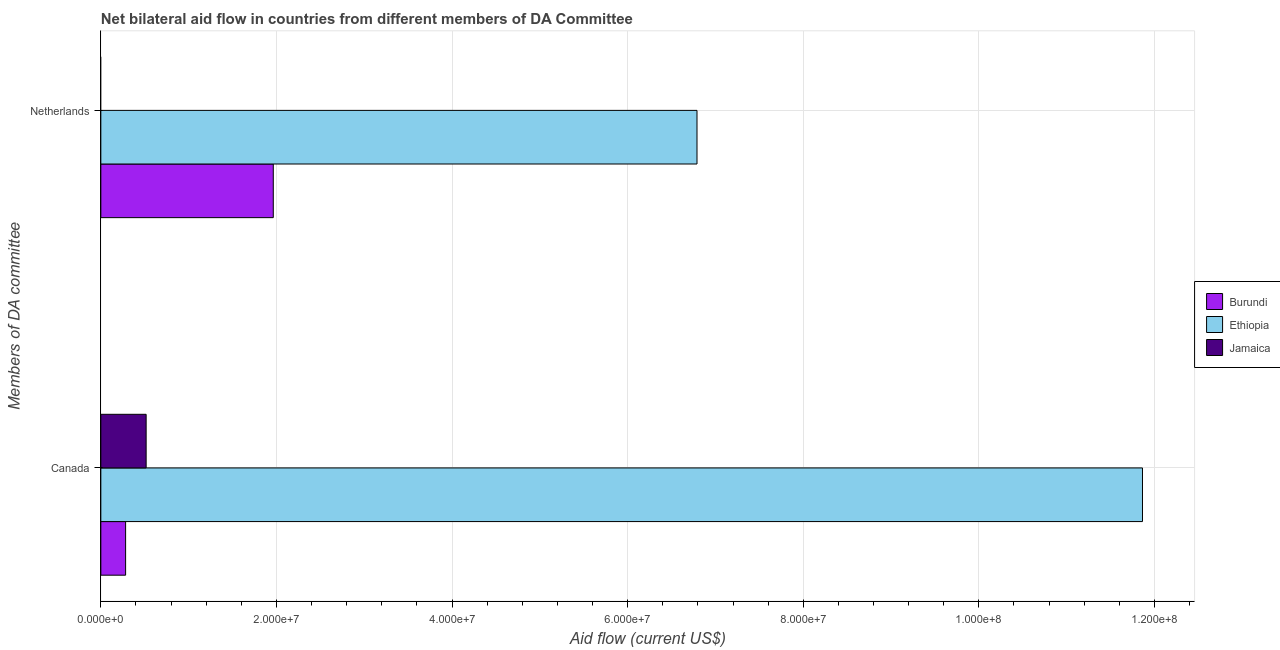How many different coloured bars are there?
Your answer should be very brief. 3. How many groups of bars are there?
Your answer should be very brief. 2. Are the number of bars on each tick of the Y-axis equal?
Your response must be concise. No. How many bars are there on the 1st tick from the top?
Provide a succinct answer. 2. What is the amount of aid given by netherlands in Ethiopia?
Keep it short and to the point. 6.79e+07. Across all countries, what is the maximum amount of aid given by canada?
Your answer should be very brief. 1.19e+08. Across all countries, what is the minimum amount of aid given by canada?
Ensure brevity in your answer.  2.82e+06. In which country was the amount of aid given by netherlands maximum?
Keep it short and to the point. Ethiopia. What is the total amount of aid given by netherlands in the graph?
Make the answer very short. 8.75e+07. What is the difference between the amount of aid given by netherlands in Burundi and that in Ethiopia?
Give a very brief answer. -4.83e+07. What is the difference between the amount of aid given by canada in Burundi and the amount of aid given by netherlands in Ethiopia?
Your response must be concise. -6.51e+07. What is the average amount of aid given by canada per country?
Offer a very short reply. 4.22e+07. What is the difference between the amount of aid given by canada and amount of aid given by netherlands in Burundi?
Offer a terse response. -1.68e+07. What is the ratio of the amount of aid given by canada in Jamaica to that in Burundi?
Your answer should be very brief. 1.83. How many bars are there?
Keep it short and to the point. 5. Are all the bars in the graph horizontal?
Your response must be concise. Yes. How many countries are there in the graph?
Your answer should be very brief. 3. Does the graph contain any zero values?
Offer a very short reply. Yes. Where does the legend appear in the graph?
Offer a very short reply. Center right. What is the title of the graph?
Provide a succinct answer. Net bilateral aid flow in countries from different members of DA Committee. What is the label or title of the X-axis?
Make the answer very short. Aid flow (current US$). What is the label or title of the Y-axis?
Offer a terse response. Members of DA committee. What is the Aid flow (current US$) in Burundi in Canada?
Keep it short and to the point. 2.82e+06. What is the Aid flow (current US$) of Ethiopia in Canada?
Ensure brevity in your answer.  1.19e+08. What is the Aid flow (current US$) of Jamaica in Canada?
Offer a very short reply. 5.16e+06. What is the Aid flow (current US$) of Burundi in Netherlands?
Offer a terse response. 1.96e+07. What is the Aid flow (current US$) of Ethiopia in Netherlands?
Keep it short and to the point. 6.79e+07. Across all Members of DA committee, what is the maximum Aid flow (current US$) in Burundi?
Provide a short and direct response. 1.96e+07. Across all Members of DA committee, what is the maximum Aid flow (current US$) in Ethiopia?
Give a very brief answer. 1.19e+08. Across all Members of DA committee, what is the maximum Aid flow (current US$) in Jamaica?
Ensure brevity in your answer.  5.16e+06. Across all Members of DA committee, what is the minimum Aid flow (current US$) of Burundi?
Your response must be concise. 2.82e+06. Across all Members of DA committee, what is the minimum Aid flow (current US$) in Ethiopia?
Provide a short and direct response. 6.79e+07. Across all Members of DA committee, what is the minimum Aid flow (current US$) of Jamaica?
Provide a short and direct response. 0. What is the total Aid flow (current US$) in Burundi in the graph?
Keep it short and to the point. 2.25e+07. What is the total Aid flow (current US$) in Ethiopia in the graph?
Your response must be concise. 1.87e+08. What is the total Aid flow (current US$) in Jamaica in the graph?
Your response must be concise. 5.16e+06. What is the difference between the Aid flow (current US$) in Burundi in Canada and that in Netherlands?
Your response must be concise. -1.68e+07. What is the difference between the Aid flow (current US$) of Ethiopia in Canada and that in Netherlands?
Make the answer very short. 5.07e+07. What is the difference between the Aid flow (current US$) of Burundi in Canada and the Aid flow (current US$) of Ethiopia in Netherlands?
Your response must be concise. -6.51e+07. What is the average Aid flow (current US$) in Burundi per Members of DA committee?
Offer a terse response. 1.12e+07. What is the average Aid flow (current US$) in Ethiopia per Members of DA committee?
Make the answer very short. 9.33e+07. What is the average Aid flow (current US$) in Jamaica per Members of DA committee?
Ensure brevity in your answer.  2.58e+06. What is the difference between the Aid flow (current US$) of Burundi and Aid flow (current US$) of Ethiopia in Canada?
Give a very brief answer. -1.16e+08. What is the difference between the Aid flow (current US$) in Burundi and Aid flow (current US$) in Jamaica in Canada?
Offer a terse response. -2.34e+06. What is the difference between the Aid flow (current US$) in Ethiopia and Aid flow (current US$) in Jamaica in Canada?
Provide a short and direct response. 1.13e+08. What is the difference between the Aid flow (current US$) in Burundi and Aid flow (current US$) in Ethiopia in Netherlands?
Offer a very short reply. -4.83e+07. What is the ratio of the Aid flow (current US$) of Burundi in Canada to that in Netherlands?
Offer a terse response. 0.14. What is the ratio of the Aid flow (current US$) in Ethiopia in Canada to that in Netherlands?
Your response must be concise. 1.75. What is the difference between the highest and the second highest Aid flow (current US$) in Burundi?
Provide a succinct answer. 1.68e+07. What is the difference between the highest and the second highest Aid flow (current US$) of Ethiopia?
Give a very brief answer. 5.07e+07. What is the difference between the highest and the lowest Aid flow (current US$) in Burundi?
Your answer should be compact. 1.68e+07. What is the difference between the highest and the lowest Aid flow (current US$) of Ethiopia?
Give a very brief answer. 5.07e+07. What is the difference between the highest and the lowest Aid flow (current US$) in Jamaica?
Provide a succinct answer. 5.16e+06. 